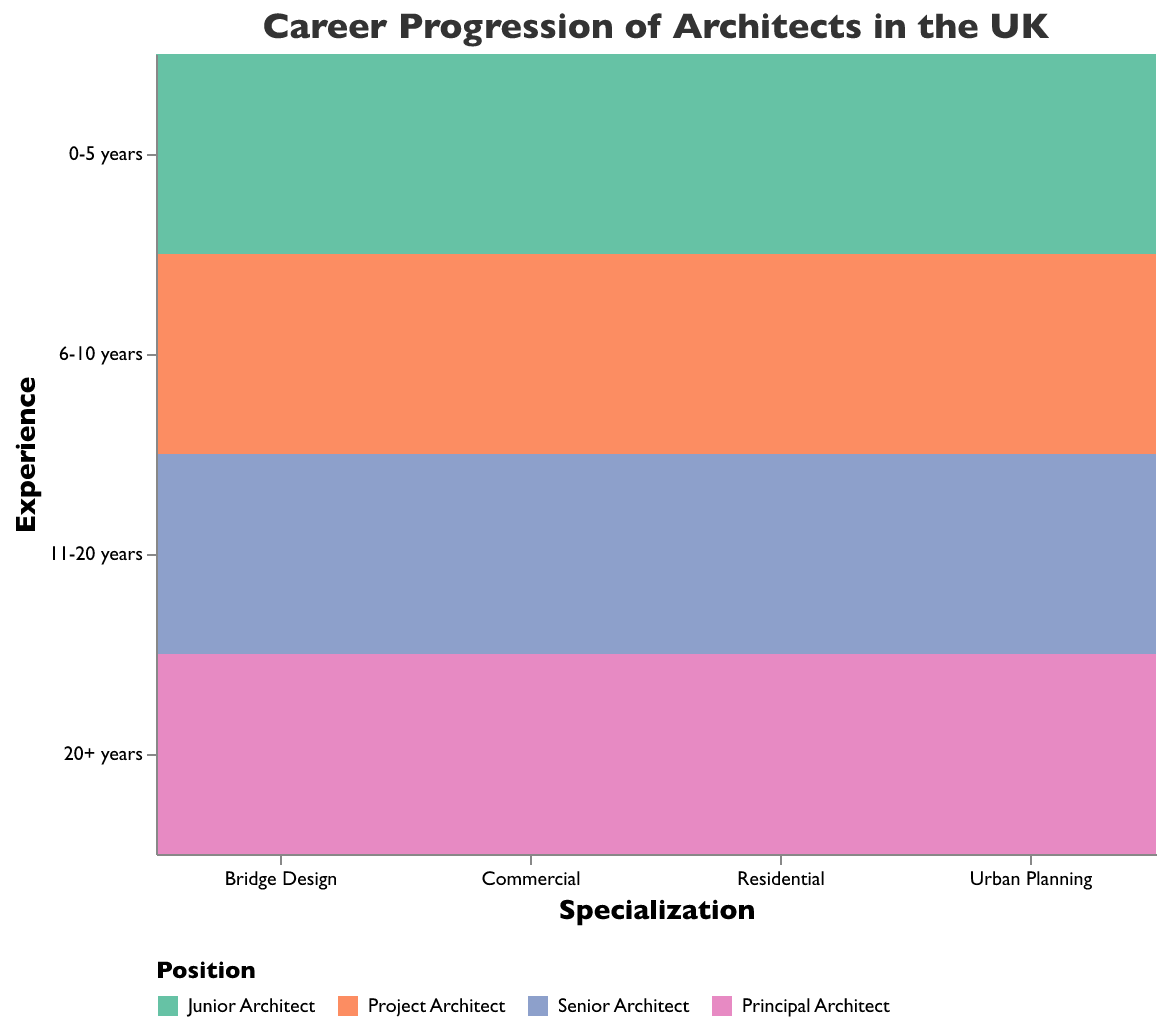What is the highest percentage of Principal Architects among the specializations? Look for the highest value in the “Principal Architect” category across all specializations. Bridge Design has the highest percentage at 35%.
Answer: 35% Which specialization has the smallest percentage of Junior Architects with 0-5 years of experience? Compare the values for “Junior Architect” with “0-5 years” across all specializations. Bridge Design has the smallest percentage at 15%.
Answer: Bridge Design In Urban Planning, what is the difference in percentage between Senior Architects with 11-20 years of experience and Principal Architects with 20+ years of experience? Find the percentage for both: 30% for Senior Architects and 27% for Principal Architects. The difference is 30% - 27% = 3%.
Answer: 3% Which specialization has a higher percentage of Senior Architects with 11-20 years of experience, Urban Planning or Residential? Compare the values for Senior Architects with 11-20 years of experience in both specializations. Urban Planning has 30%, and Residential has 32%, so Residential is higher.
Answer: Residential In the Commercial specialization, what is the combined percentage of Project Architects with 6-10 years of experience and Senior Architects with 11-20 years of experience? Add the percentages for Project Architects (26%) and Senior Architects (31%): 26% + 31% = 57%.
Answer: 57% How do the percentages of Principal Architects with 20+ years of experience compare between Bridge Design and Commercial specializations? Compare the values: Bridge Design is 35% and Commercial is 26%. Bridge Design has a higher percentage.
Answer: Bridge Design What is the total percentage of Junior Architects with 0-5 years of experience across all specializations? Sum the percentages: 15% (Bridge Design) + 18% (Urban Planning) + 20% (Residential) + 17% (Commercial) = 70%.
Answer: 70% Which specialization has the highest percentage of Project Architects with 6-10 years of experience? Compare the values for Project Architects with 6-10 years experience across all specializations. Residential has the highest percentage at 28%.
Answer: Residential Is the percentage of Principal Architects with 20+ years of experience higher in Urban Planning or Commercial specialization? Compare the percentages: Urban Planning has 27% and Commercial has 26%. Urban Planning is higher.
Answer: Urban Planning 